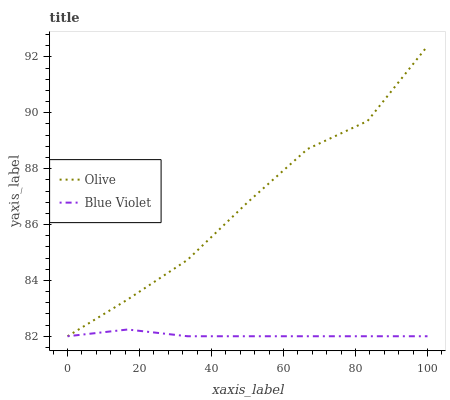Does Blue Violet have the maximum area under the curve?
Answer yes or no. No. Is Blue Violet the roughest?
Answer yes or no. No. Does Blue Violet have the highest value?
Answer yes or no. No. 